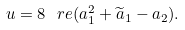<formula> <loc_0><loc_0><loc_500><loc_500>u = 8 \ r e ( a _ { 1 } ^ { 2 } + \widetilde { a } _ { 1 } - a _ { 2 } ) .</formula> 